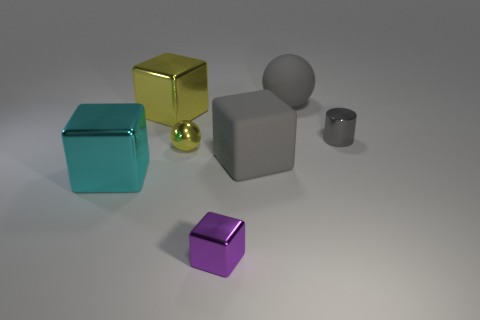Subtract all cyan cubes. How many cubes are left? 3 Subtract all tiny purple blocks. How many blocks are left? 3 Subtract all red cubes. Subtract all yellow balls. How many cubes are left? 4 Add 1 gray things. How many objects exist? 8 Subtract all cylinders. How many objects are left? 6 Add 7 big yellow shiny blocks. How many big yellow shiny blocks are left? 8 Add 7 small purple cylinders. How many small purple cylinders exist? 7 Subtract 1 gray cylinders. How many objects are left? 6 Subtract all blocks. Subtract all metal cylinders. How many objects are left? 2 